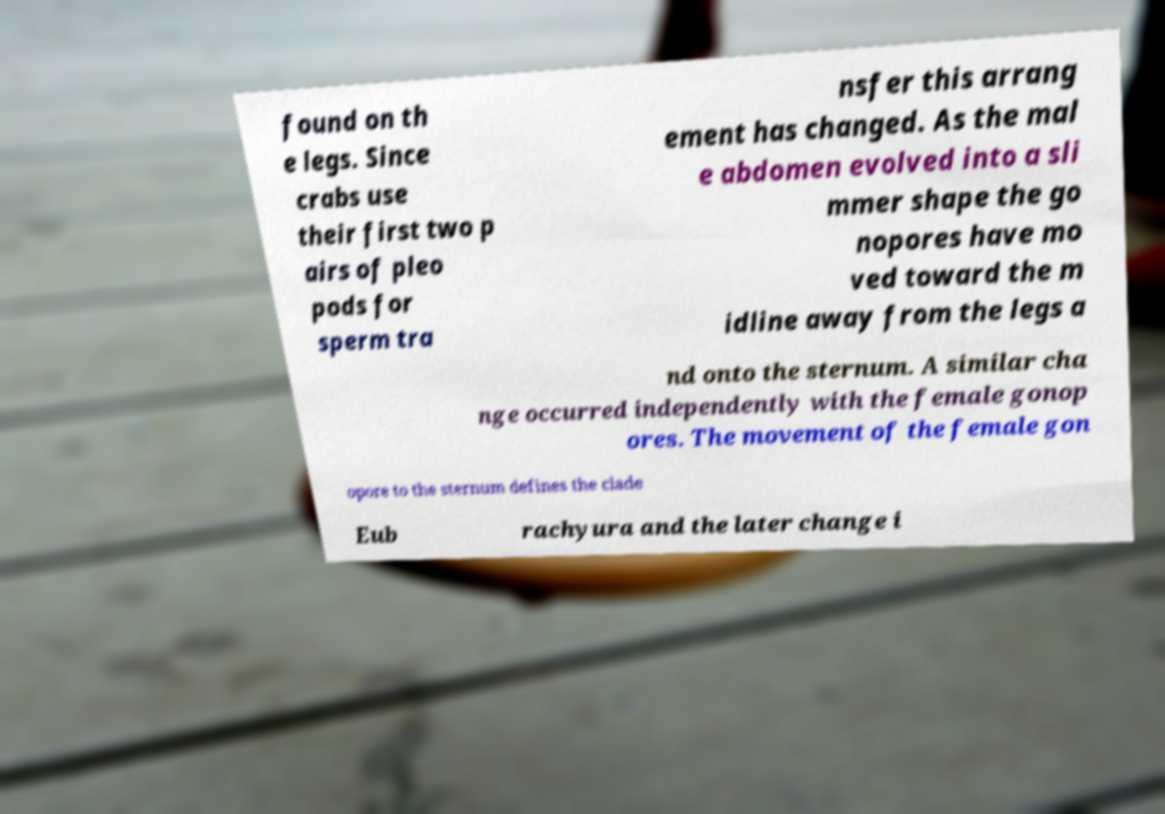There's text embedded in this image that I need extracted. Can you transcribe it verbatim? found on th e legs. Since crabs use their first two p airs of pleo pods for sperm tra nsfer this arrang ement has changed. As the mal e abdomen evolved into a sli mmer shape the go nopores have mo ved toward the m idline away from the legs a nd onto the sternum. A similar cha nge occurred independently with the female gonop ores. The movement of the female gon opore to the sternum defines the clade Eub rachyura and the later change i 